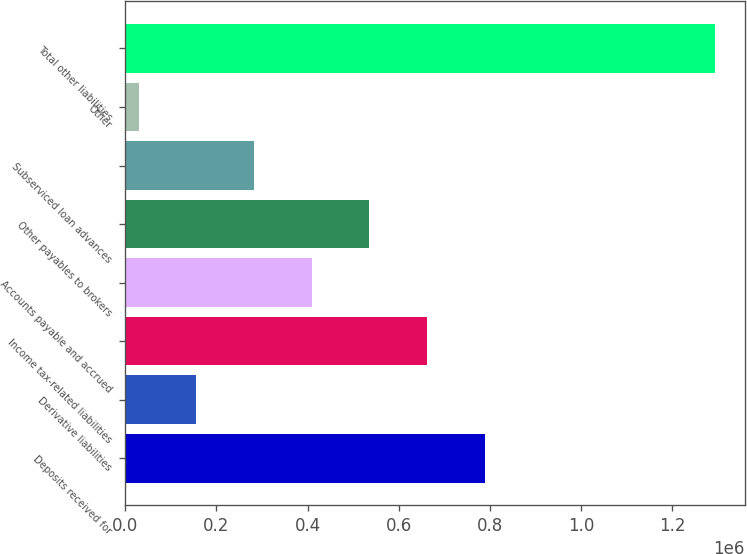Convert chart to OTSL. <chart><loc_0><loc_0><loc_500><loc_500><bar_chart><fcel>Deposits received for<fcel>Derivative liabilities<fcel>Income tax-related liabilities<fcel>Accounts payable and accrued<fcel>Other payables to brokers<fcel>Subserviced loan advances<fcel>Other<fcel>Total other liabilities<nl><fcel>788482<fcel>156173<fcel>662020<fcel>409096<fcel>535558<fcel>282635<fcel>29711<fcel>1.29433e+06<nl></chart> 